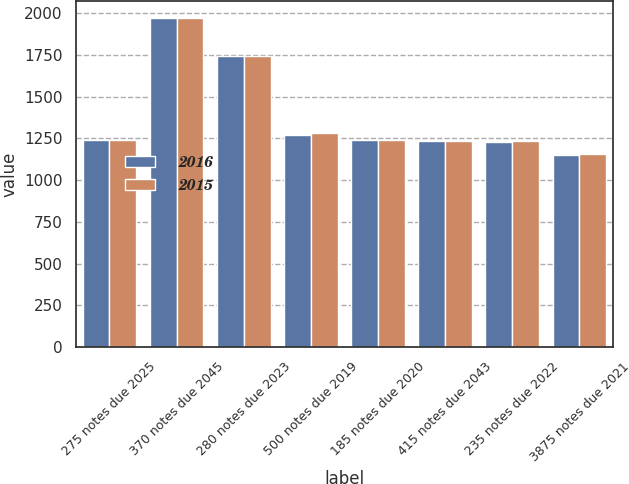Convert chart. <chart><loc_0><loc_0><loc_500><loc_500><stacked_bar_chart><ecel><fcel>275 notes due 2025<fcel>370 notes due 2045<fcel>280 notes due 2023<fcel>500 notes due 2019<fcel>185 notes due 2020<fcel>415 notes due 2043<fcel>235 notes due 2022<fcel>3875 notes due 2021<nl><fcel>2016<fcel>1238.5<fcel>1972<fcel>1743<fcel>1273<fcel>1238<fcel>1236<fcel>1228<fcel>1152<nl><fcel>2015<fcel>1238.5<fcel>1971<fcel>1742<fcel>1283<fcel>1239<fcel>1236<fcel>1233<fcel>1158<nl></chart> 